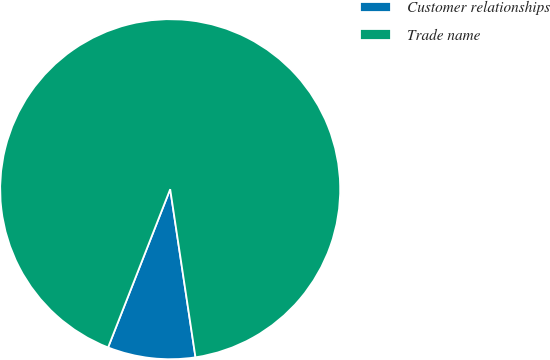<chart> <loc_0><loc_0><loc_500><loc_500><pie_chart><fcel>Customer relationships<fcel>Trade name<nl><fcel>8.33%<fcel>91.67%<nl></chart> 